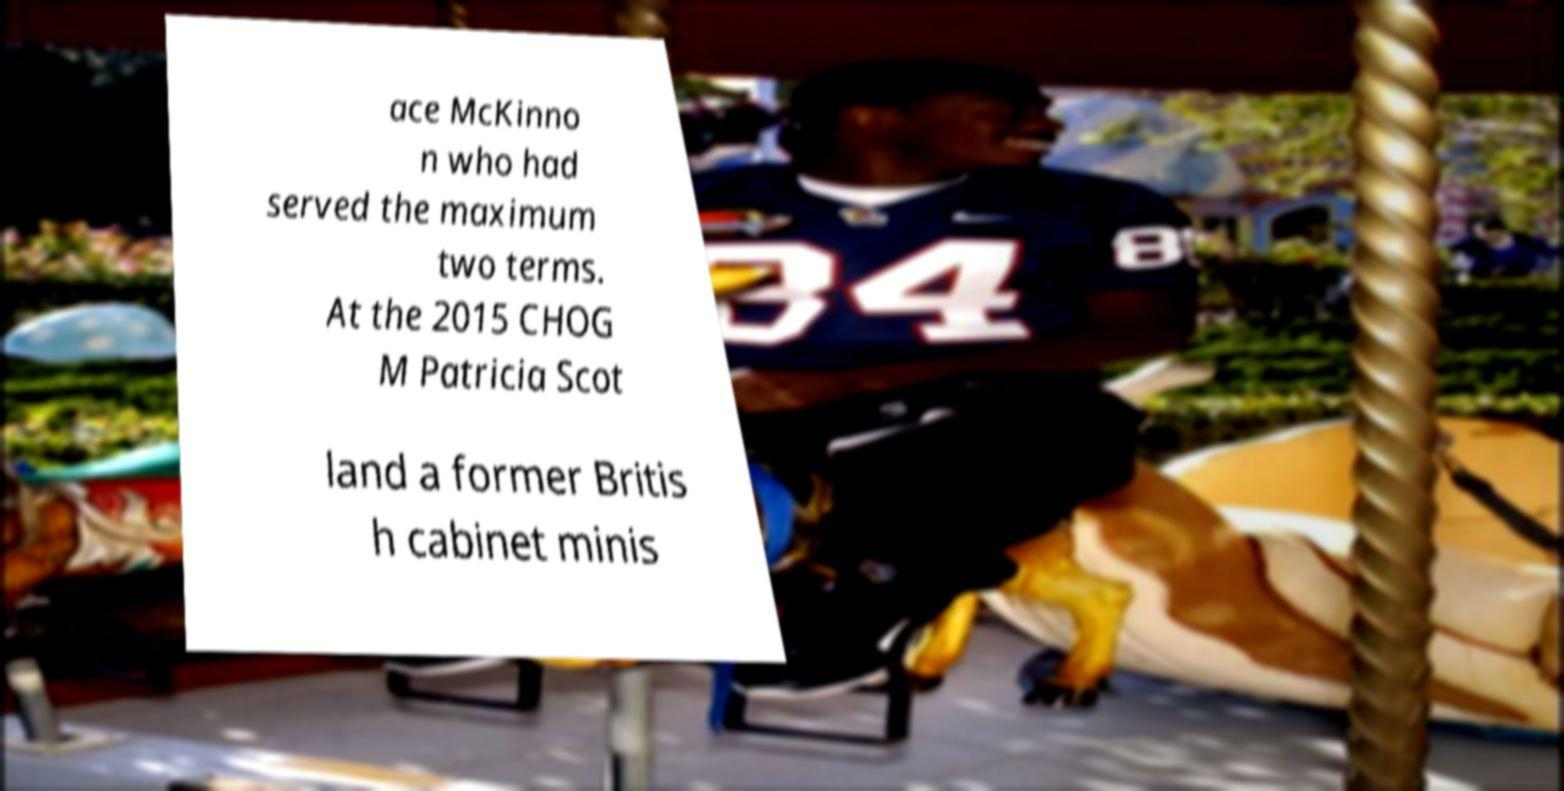What messages or text are displayed in this image? I need them in a readable, typed format. ace McKinno n who had served the maximum two terms. At the 2015 CHOG M Patricia Scot land a former Britis h cabinet minis 